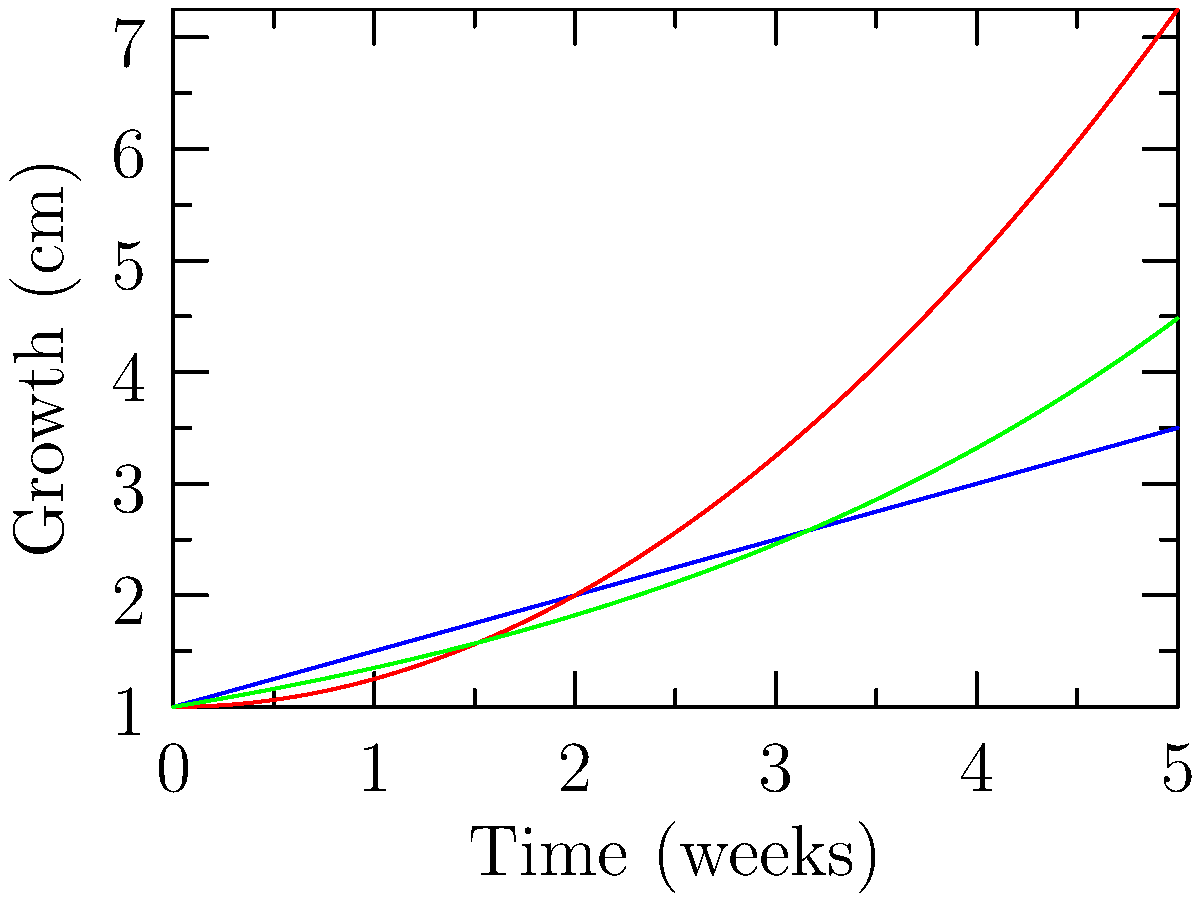As a young farmer interested in giving back to your community, you're experimenting with different crop varieties to maximize yield for a local food bank. The graph shows the growth rates of three crop varieties over a 5-week period. Which variety shows the highest growth rate at the end of the 5-week period, and what type of growth does it exhibit? To answer this question, we need to analyze the growth rates of the three varieties at the end of the 5-week period:

1. Observe the slopes of each line at week 5:
   - Variety A (blue): constant slope
   - Variety B (red): increasing slope
   - Variety C (green): steepest slope at week 5

2. Compare the steepness of the slopes at week 5:
   Variety C > Variety B > Variety A

3. Identify the growth type of Variety C:
   - The curve is exponential, as it starts slowly and increases at an accelerating rate.

4. Confirm the exponential growth:
   - The y-axis values increase by larger amounts as x increases.
   - The curve becomes steeper over time.

5. Conclusion:
   Variety C shows the highest growth rate at the end of the 5-week period and exhibits exponential growth.
Answer: Variety C, exponential growth 